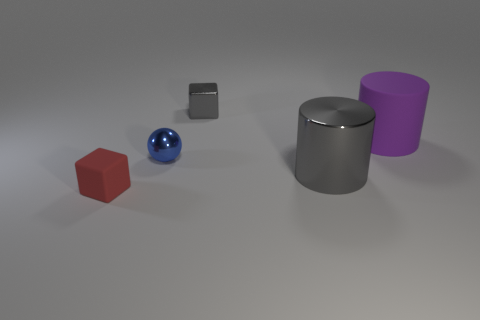Add 5 large shiny things. How many objects exist? 10 Subtract all spheres. How many objects are left? 4 Subtract all red cubes. Subtract all small gray things. How many objects are left? 3 Add 5 small blue shiny spheres. How many small blue shiny spheres are left? 6 Add 5 big gray shiny cubes. How many big gray shiny cubes exist? 5 Subtract 0 brown cylinders. How many objects are left? 5 